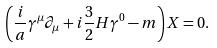<formula> <loc_0><loc_0><loc_500><loc_500>\left ( \frac { i } { a } \gamma ^ { \mu } \partial _ { \mu } + i \frac { 3 } { 2 } H \gamma ^ { 0 } - m \right ) X = 0 .</formula> 